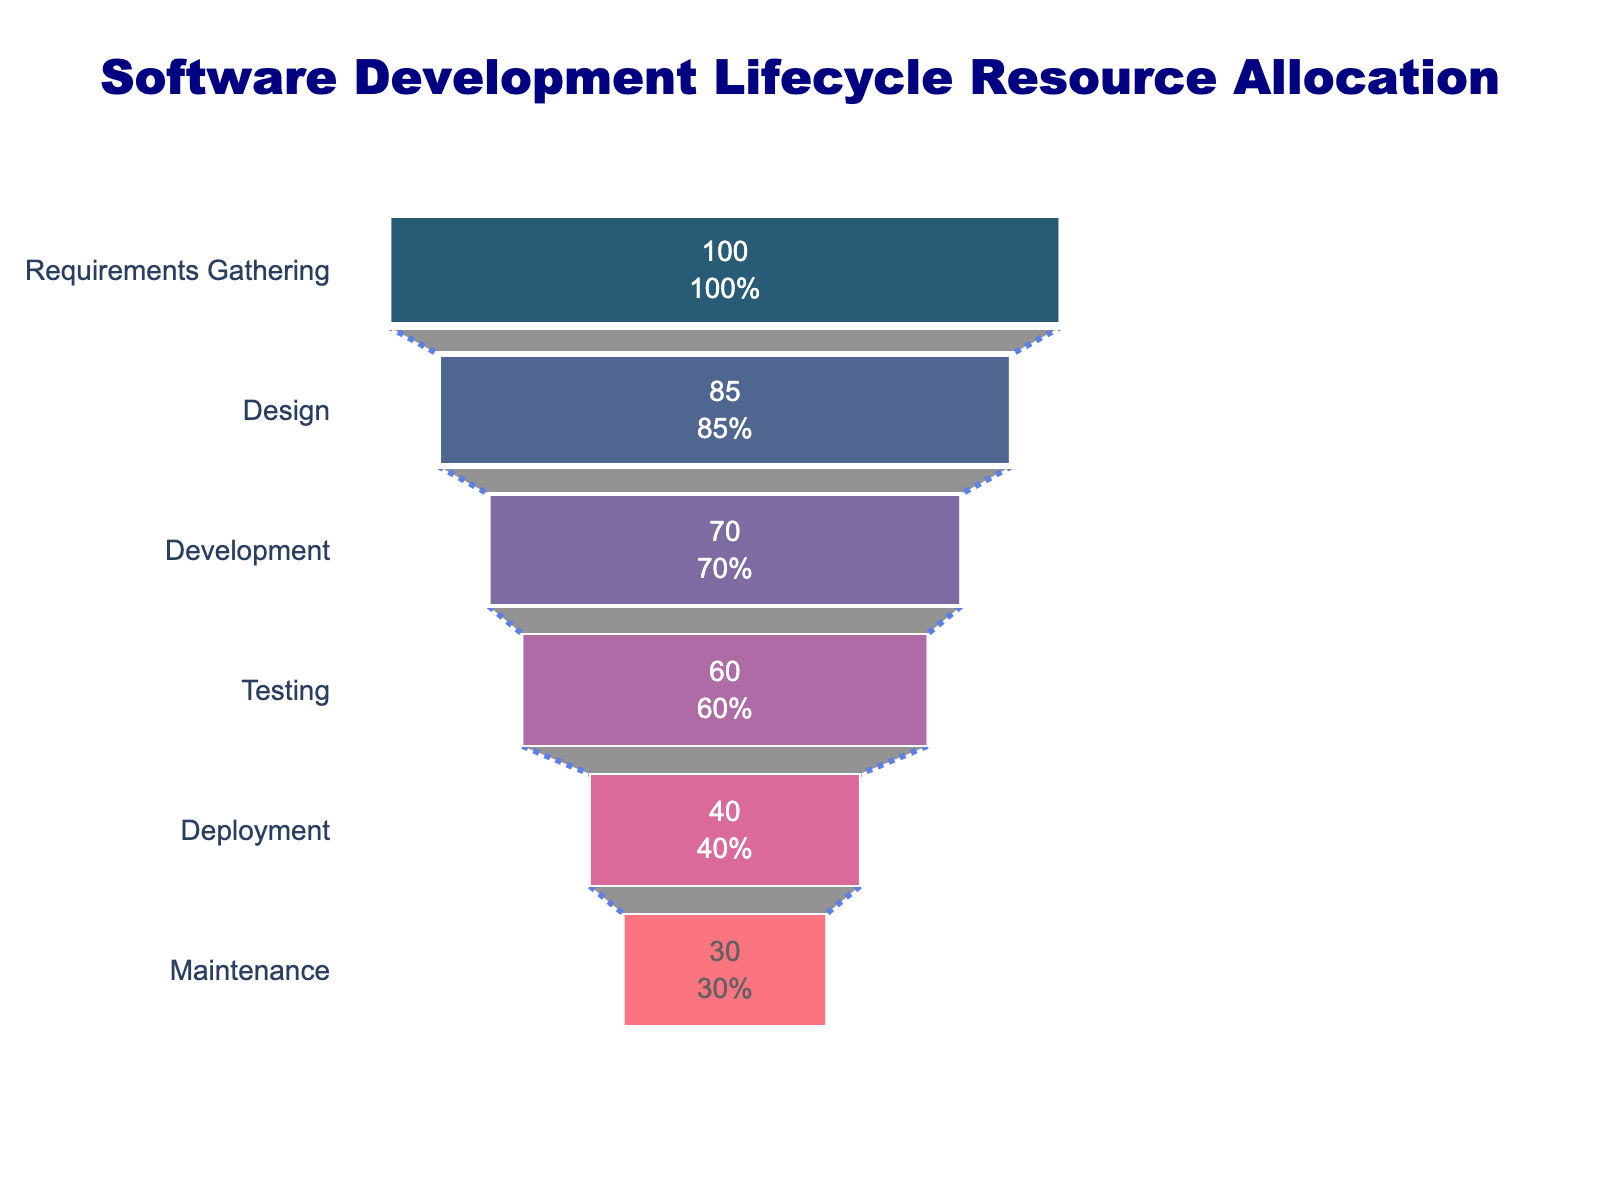What is the title of the chart? The title of the chart is displayed at the top and centered mostly, typically in a larger font size and different color. Here, it reads: "Software Development Lifecycle Resource Allocation."
Answer: Software Development Lifecycle Resource Allocation Which phase has the highest resource allocation? By looking at the top of the funnel chart, the phase with the highest resource allocation is usually listed first as the widest section. In this chart, the "Requirements Gathering" phase has 100% resource allocation.
Answer: Requirements Gathering What phase comes after Development in terms of resource allocation? Following the series of phases as we move down the funnel chart, the phase listed directly after "Development" (which has 70%) is "Testing," which has 60%.
Answer: Testing What is the resource allocation percentage for the Testing phase? Identifying the "Testing" phase on the chart and looking at the corresponding value inside the funnel, it shows 60%.
Answer: 60% What is the difference in resource allocation between the Design and Deployment phases? The "Design" phase has an allocation of 85%, and the "Deployment" phase has 40%. The difference can be calculated by subtracting 40 from 85, resulting in: 85% - 40% = 45%.
Answer: 45% How much has the resource allocation decreased from Requirements Gathering to Development? Subtract the resource allocation of "Development" (70%) from that of "Requirements Gathering" (100%). So, 100% - 70% = 30%.
Answer: 30% Which phase has the least resource allocation, and what is its percentage? The smallest section at the bottom of the funnel indicates the phase with the least resource allocation. Here it is "Maintenance" with 30%.
Answer: Maintenance, 30% How many phases have a resource allocation of 60% or more? Counting the segments from the top until we reach a phase with less than 60%, we find that "Requirements Gathering" (100%), "Design" (85%), "Development" (70%), and "Testing" (60%) meet the criteria. So there are 4 such phases.
Answer: 4 What is the average resource allocation from Development to Maintenance phases? Sum the resource allocations of "Development" (70%), "Testing" (60%), "Deployment" (40%), and "Maintenance" (30%) phases, and then divide by the number of phases: (70 + 60 + 40 + 30) / 4 = 50%.
Answer: 50% Which color represents the Testing phase, and how is it distinct? The Testing phase is represented by the color maroon (with a shade leaning towards "#a05195"). It is distinct due to both the color and the textual information inside the funnel segment denoting "60%".
Answer: Maroon (approximately #a05195) 